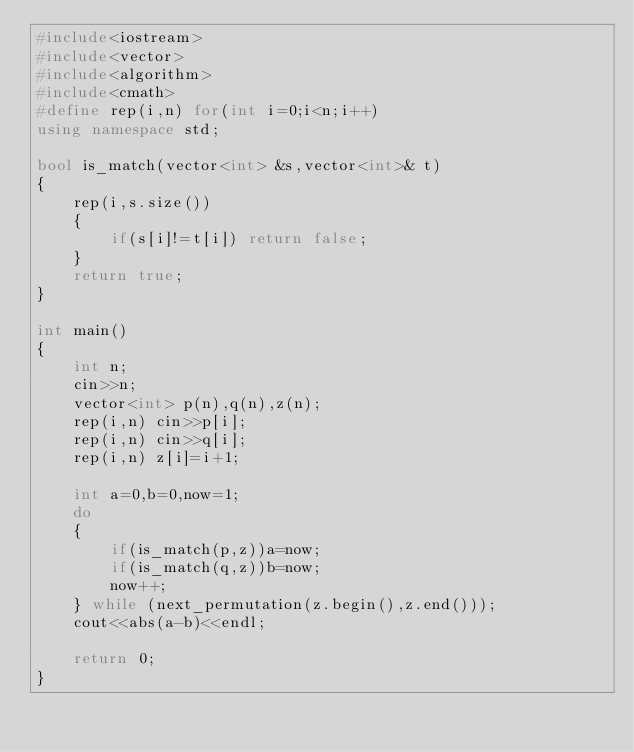Convert code to text. <code><loc_0><loc_0><loc_500><loc_500><_C++_>#include<iostream>
#include<vector>
#include<algorithm>
#include<cmath>
#define rep(i,n) for(int i=0;i<n;i++)
using namespace std;

bool is_match(vector<int> &s,vector<int>& t)
{
    rep(i,s.size())
    {
        if(s[i]!=t[i]) return false;
    }
    return true;
}

int main()
{
    int n;
    cin>>n;
    vector<int> p(n),q(n),z(n);
    rep(i,n) cin>>p[i];
    rep(i,n) cin>>q[i];
    rep(i,n) z[i]=i+1;

    int a=0,b=0,now=1;
    do
    {
        if(is_match(p,z))a=now;
        if(is_match(q,z))b=now;
        now++;
    } while (next_permutation(z.begin(),z.end()));
    cout<<abs(a-b)<<endl;

    return 0;
}</code> 